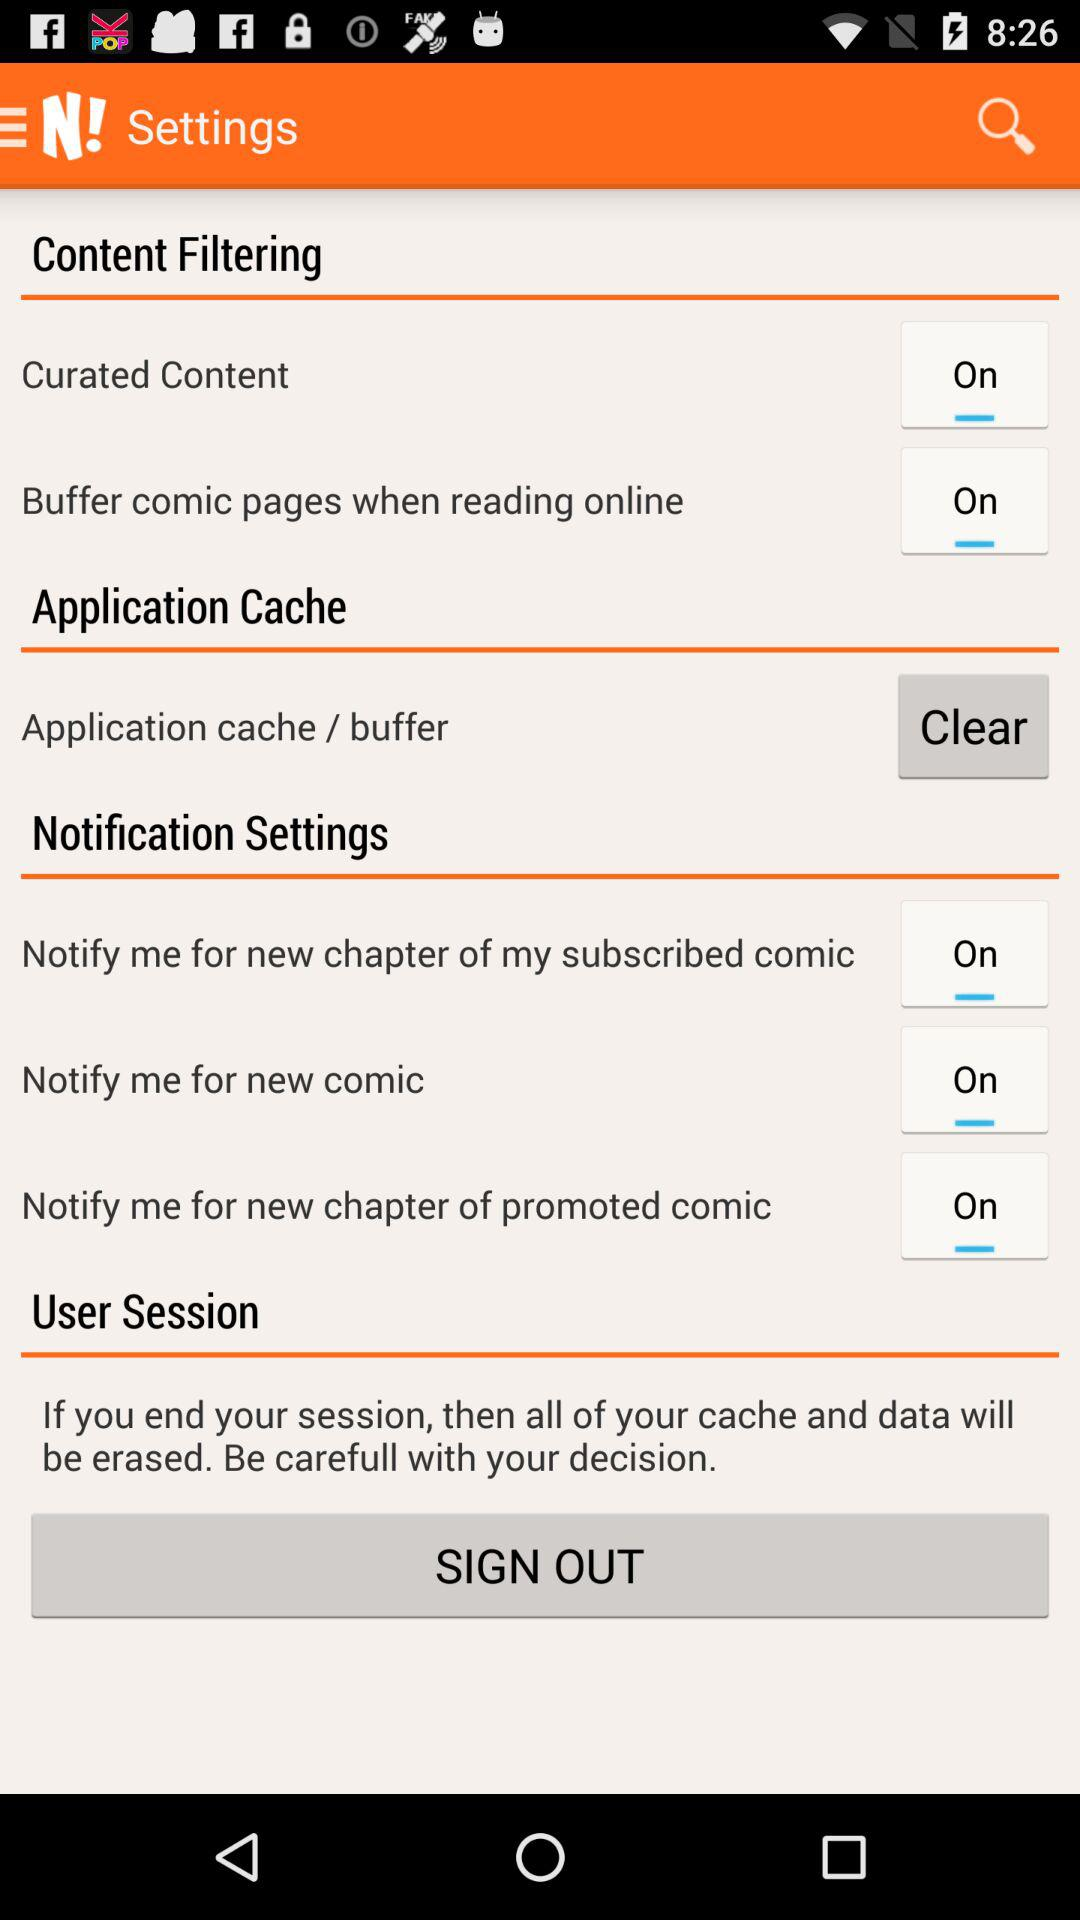What is the status of "Buffer comic pages when reading online"? The status of "Buffer comic pages when reading online" is "on". 